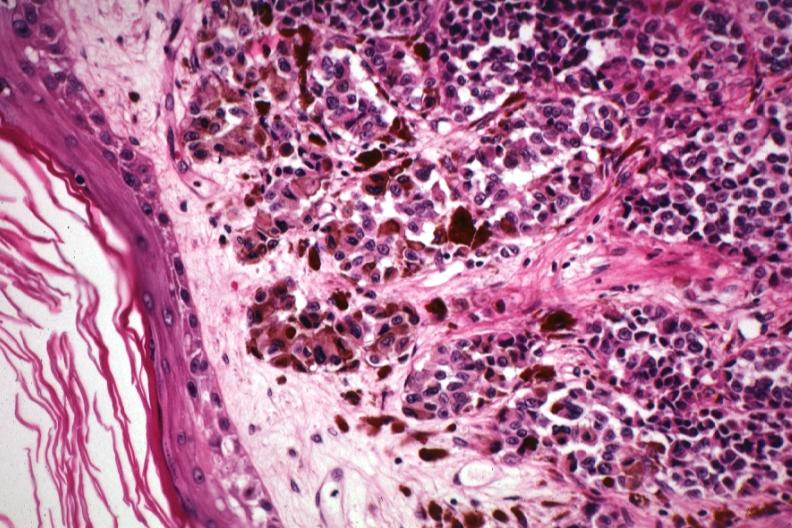what is present?
Answer the question using a single word or phrase. Malignant melanoma 